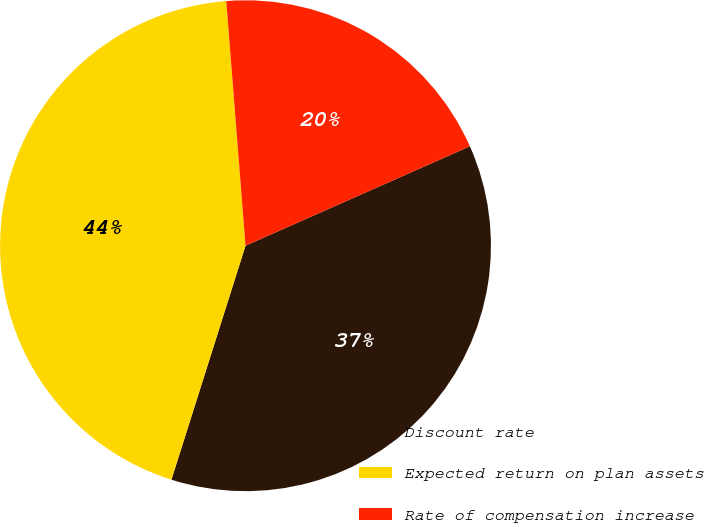Convert chart. <chart><loc_0><loc_0><loc_500><loc_500><pie_chart><fcel>Discount rate<fcel>Expected return on plan assets<fcel>Rate of compensation increase<nl><fcel>36.52%<fcel>43.87%<fcel>19.61%<nl></chart> 